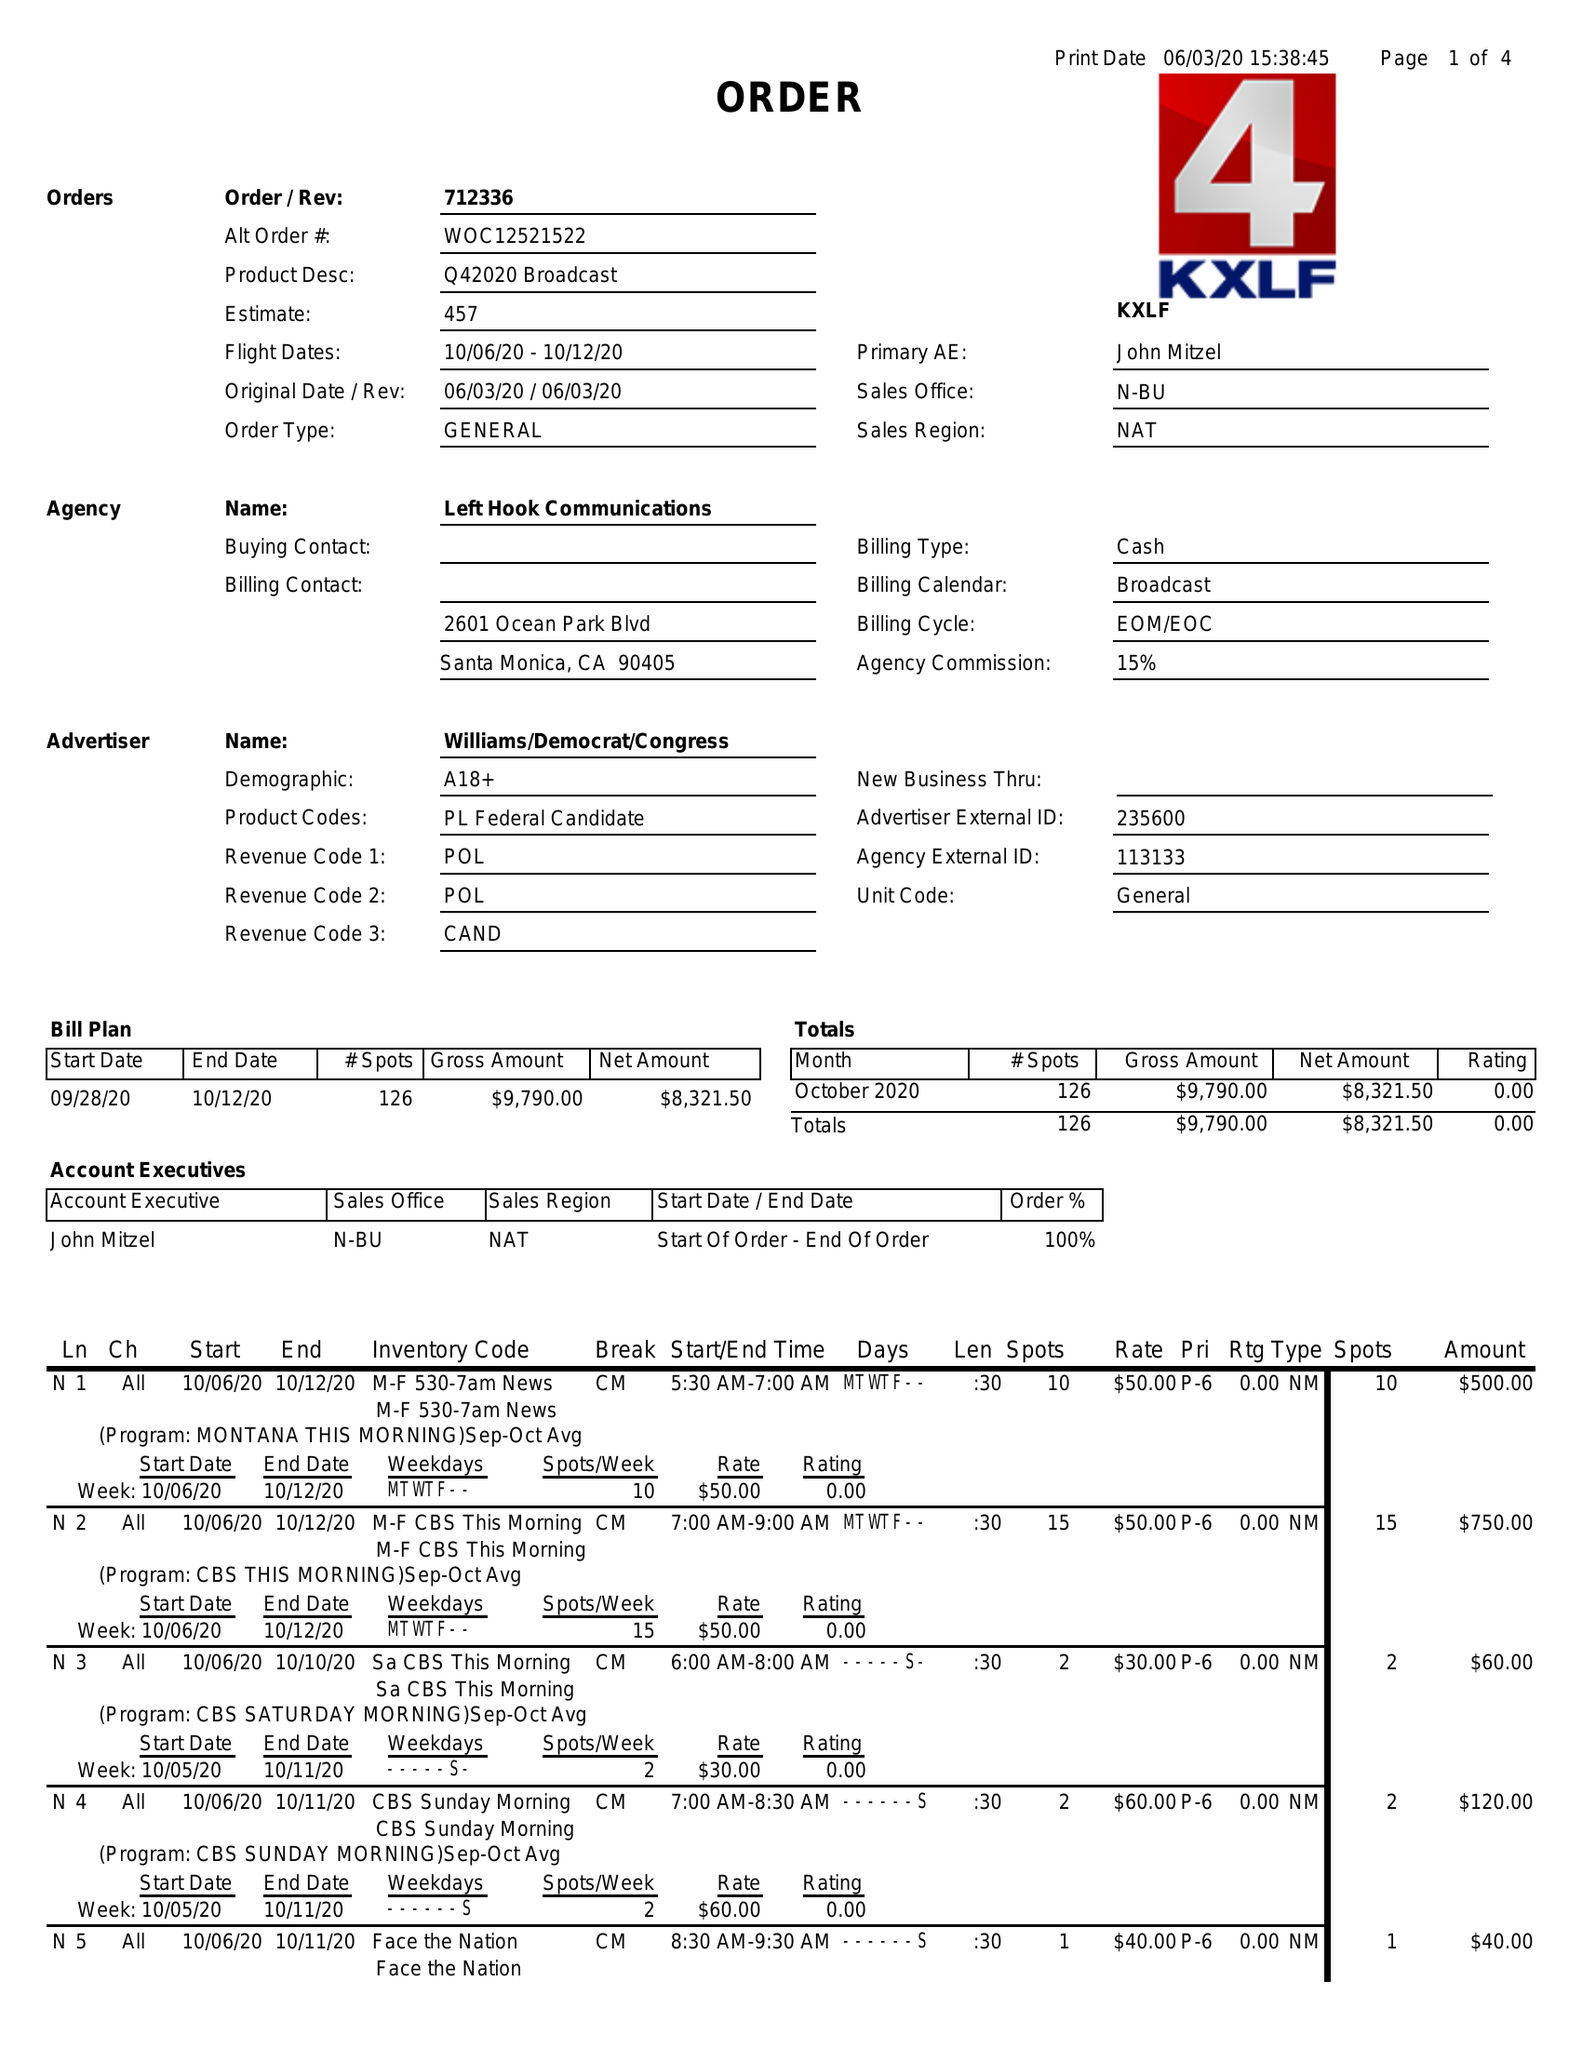What is the value for the advertiser?
Answer the question using a single word or phrase. WILLIAMS/DEMOCRAT/CONGRESS 